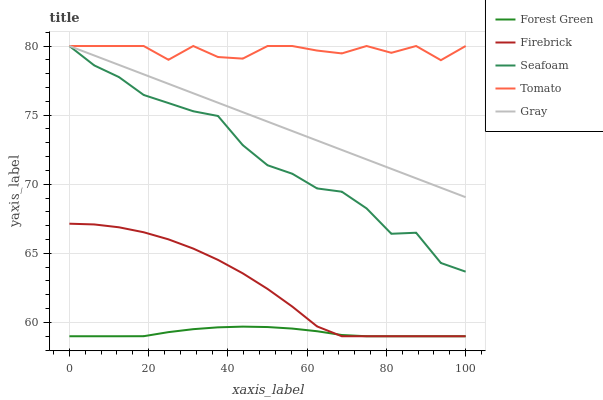Does Forest Green have the minimum area under the curve?
Answer yes or no. Yes. Does Tomato have the maximum area under the curve?
Answer yes or no. Yes. Does Gray have the minimum area under the curve?
Answer yes or no. No. Does Gray have the maximum area under the curve?
Answer yes or no. No. Is Gray the smoothest?
Answer yes or no. Yes. Is Tomato the roughest?
Answer yes or no. Yes. Is Forest Green the smoothest?
Answer yes or no. No. Is Forest Green the roughest?
Answer yes or no. No. Does Forest Green have the lowest value?
Answer yes or no. Yes. Does Gray have the lowest value?
Answer yes or no. No. Does Seafoam have the highest value?
Answer yes or no. Yes. Does Forest Green have the highest value?
Answer yes or no. No. Is Forest Green less than Gray?
Answer yes or no. Yes. Is Gray greater than Firebrick?
Answer yes or no. Yes. Does Forest Green intersect Firebrick?
Answer yes or no. Yes. Is Forest Green less than Firebrick?
Answer yes or no. No. Is Forest Green greater than Firebrick?
Answer yes or no. No. Does Forest Green intersect Gray?
Answer yes or no. No. 